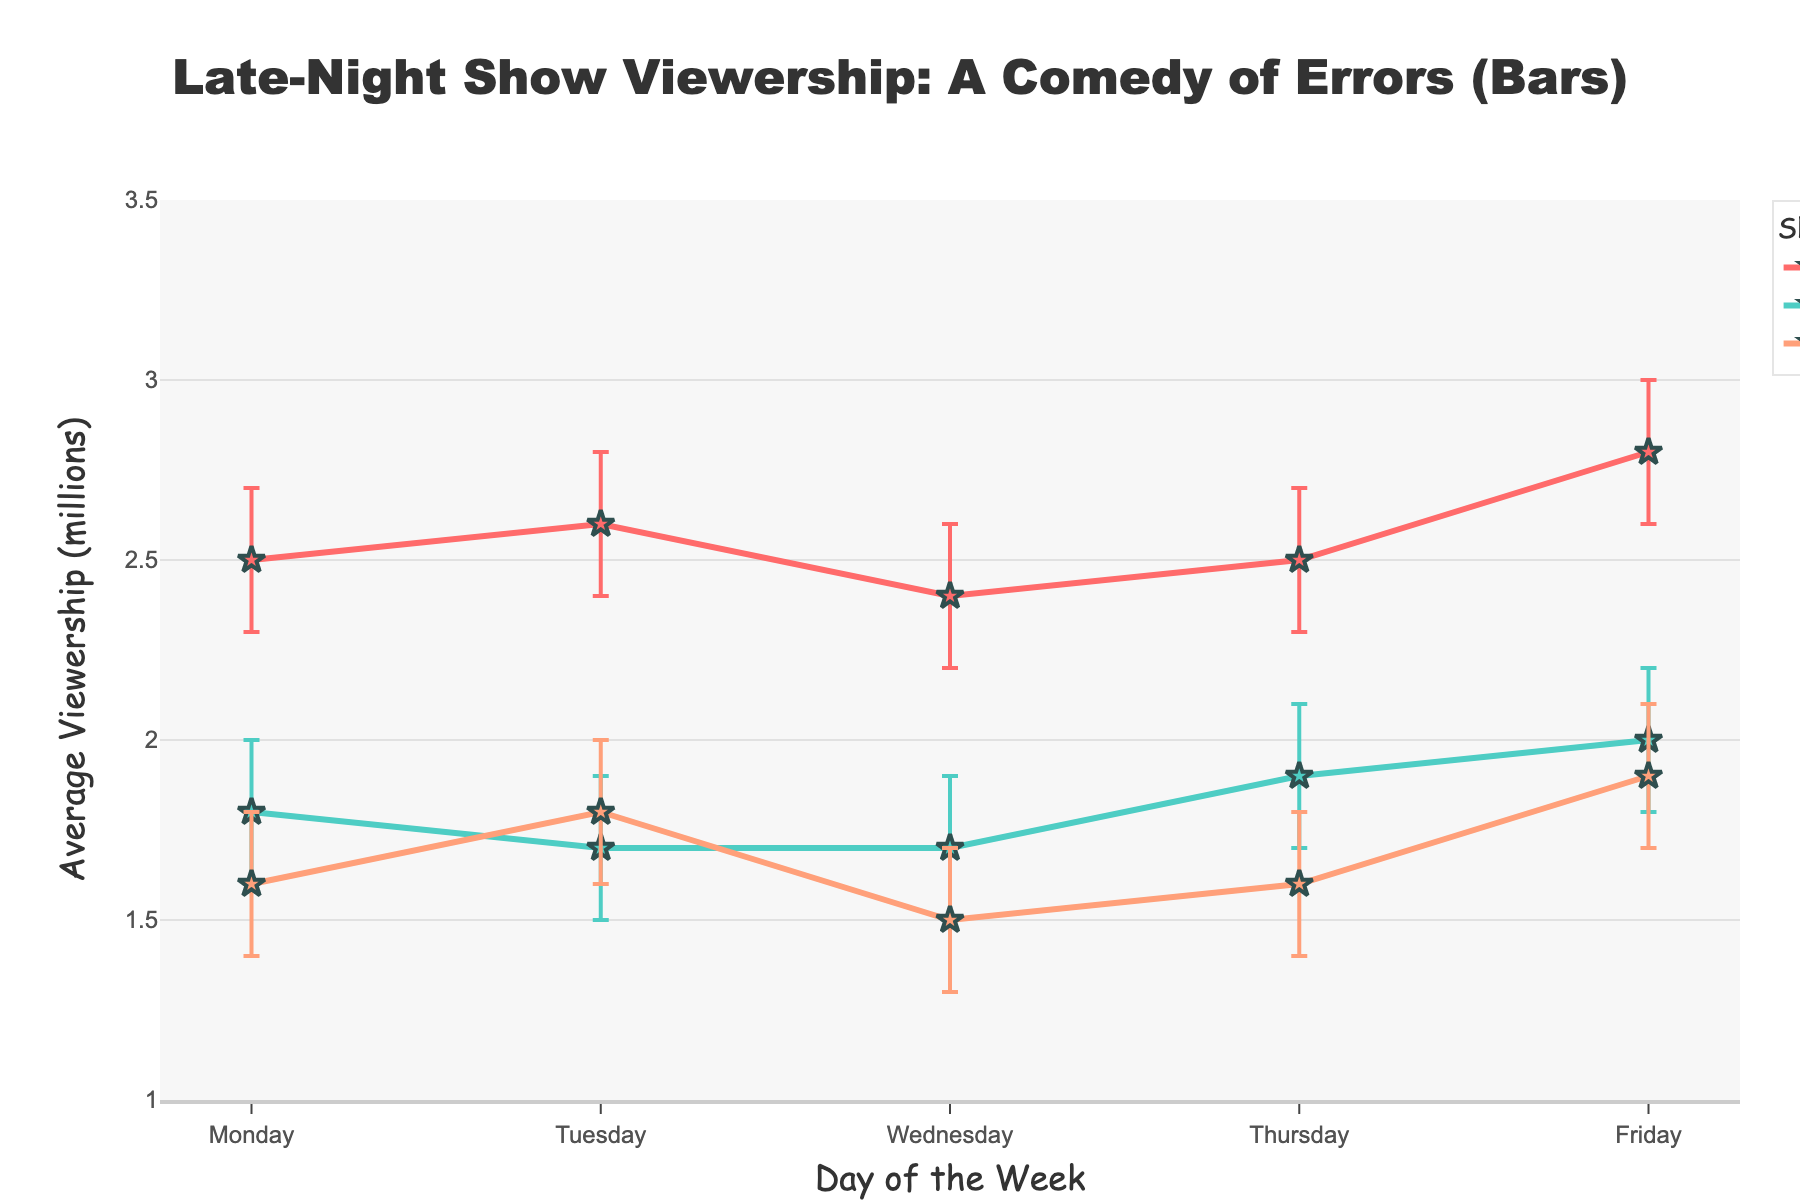What's the title of the figure? The title of the figure is displayed prominently at the top.
Answer: Late-Night Show Viewership: A Comedy of Errors (Bars) Which show had the highest viewership on Friday? Look at the data points for Friday and identify which show has the highest y-value for average viewership.
Answer: The Late Show with Stephen Colbert What is the average viewership of Jimmy Kimmel Live! on Tuesday? Find the data point for Jimmy Kimmel Live! on Tuesday and read off the y-axis value for average viewership.
Answer: 1.8 million On which day did The Tonight Show Starring Jimmy Fallon have its lowest viewership? Locate the data points for The Tonight Show Starring Jimmy Fallon and identify the one with the lowest y-value.
Answer: Tuesday How much higher was the viewership for The Late Show with Stephen Colbert on Friday compared to Monday? Subtract the Monday viewership value of The Late Show with Stephen Colbert from its Friday viewership value.
Answer: 0.3 million What is the confidence interval range for The Tonight Show Starring Jimmy Fallon on Thursday? Find the error bars for The Tonight Show Starring Jimmy Fallon on Thursday and calculate the difference between the upper and lower confidence intervals.
Answer: 0.4 million Which show had the most consistent viewership throughout the week? Evaluate the shows by comparing the differences in average viewership values and error bars from Monday to Friday and see which show has the least variation.
Answer: The Tonight Show Starring Jimmy Fallon If you're deciding which show to watch based on the lowest uncertainty, which one should you pick on Wednesday? Compare the lengths of the error bars for all three shows on Wednesday and choose the one with the smallest error bar (shortest range).
Answer: The Tonight Show Starring Jimmy Fallon How did the viewership for Jimmy Kimmel Live! change from Monday to Wednesday? Look at the viewership values for Jimmy Kimmel Live! on Monday and Wednesday and note the change by subtracting the Monday value from the Wednesday value.
Answer: Decreased by 0.1 million What's the difference in viewership between The Late Show with Stephen Colbert on Tuesday and The Tonight Show Starring Jimmy Fallon on Thursday? Subtract the viewership value of The Tonight Show Starring Jimmy Fallon on Thursday from The Late Show with Stephen Colbert on Tuesday.
Answer: 0.7 million 